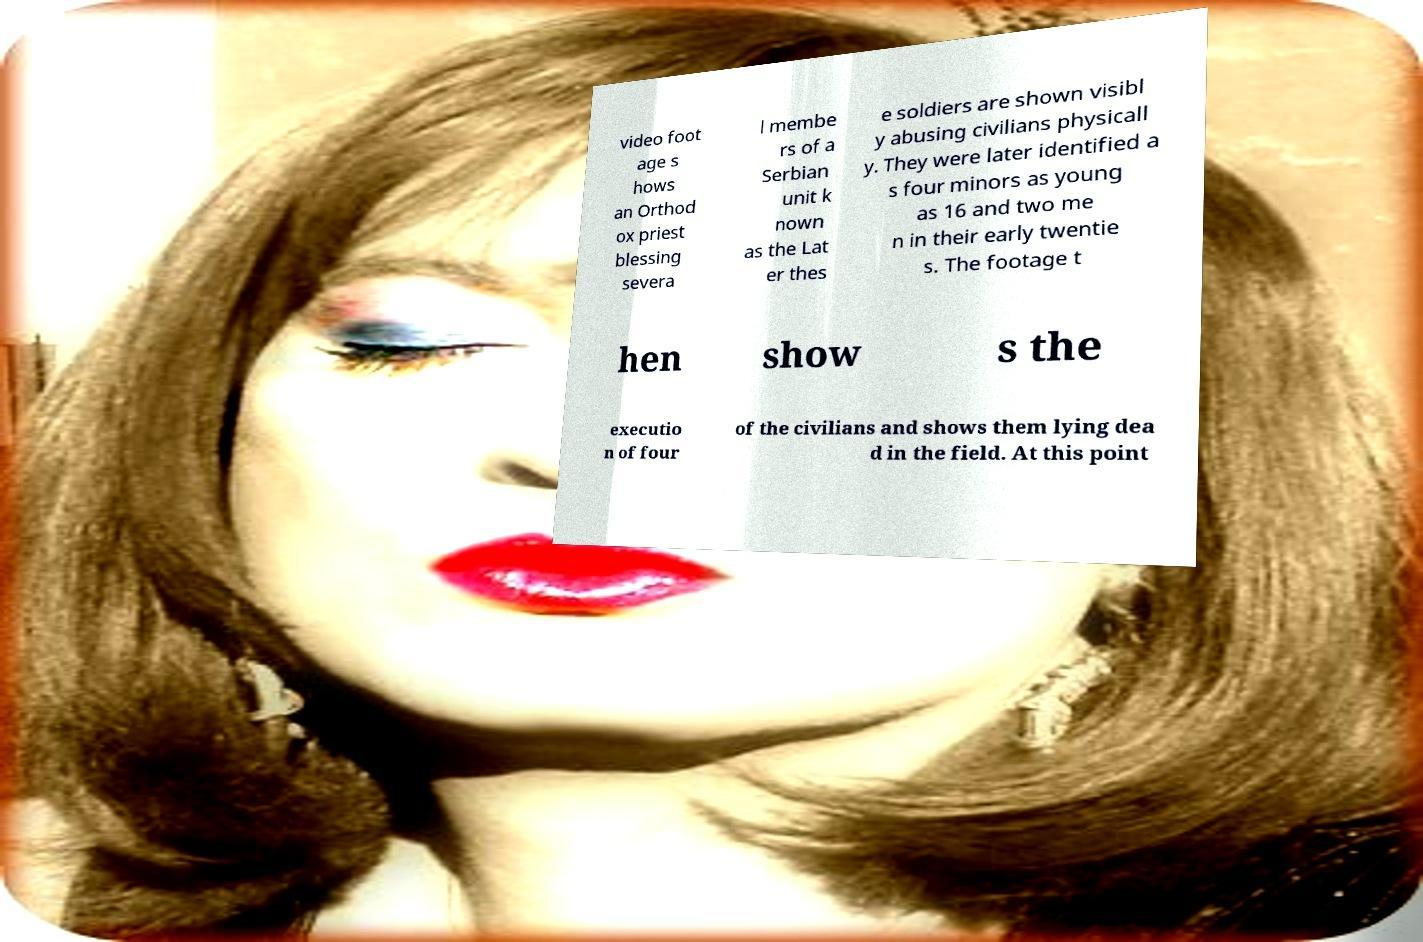Please read and relay the text visible in this image. What does it say? video foot age s hows an Orthod ox priest blessing severa l membe rs of a Serbian unit k nown as the Lat er thes e soldiers are shown visibl y abusing civilians physicall y. They were later identified a s four minors as young as 16 and two me n in their early twentie s. The footage t hen show s the executio n of four of the civilians and shows them lying dea d in the field. At this point 